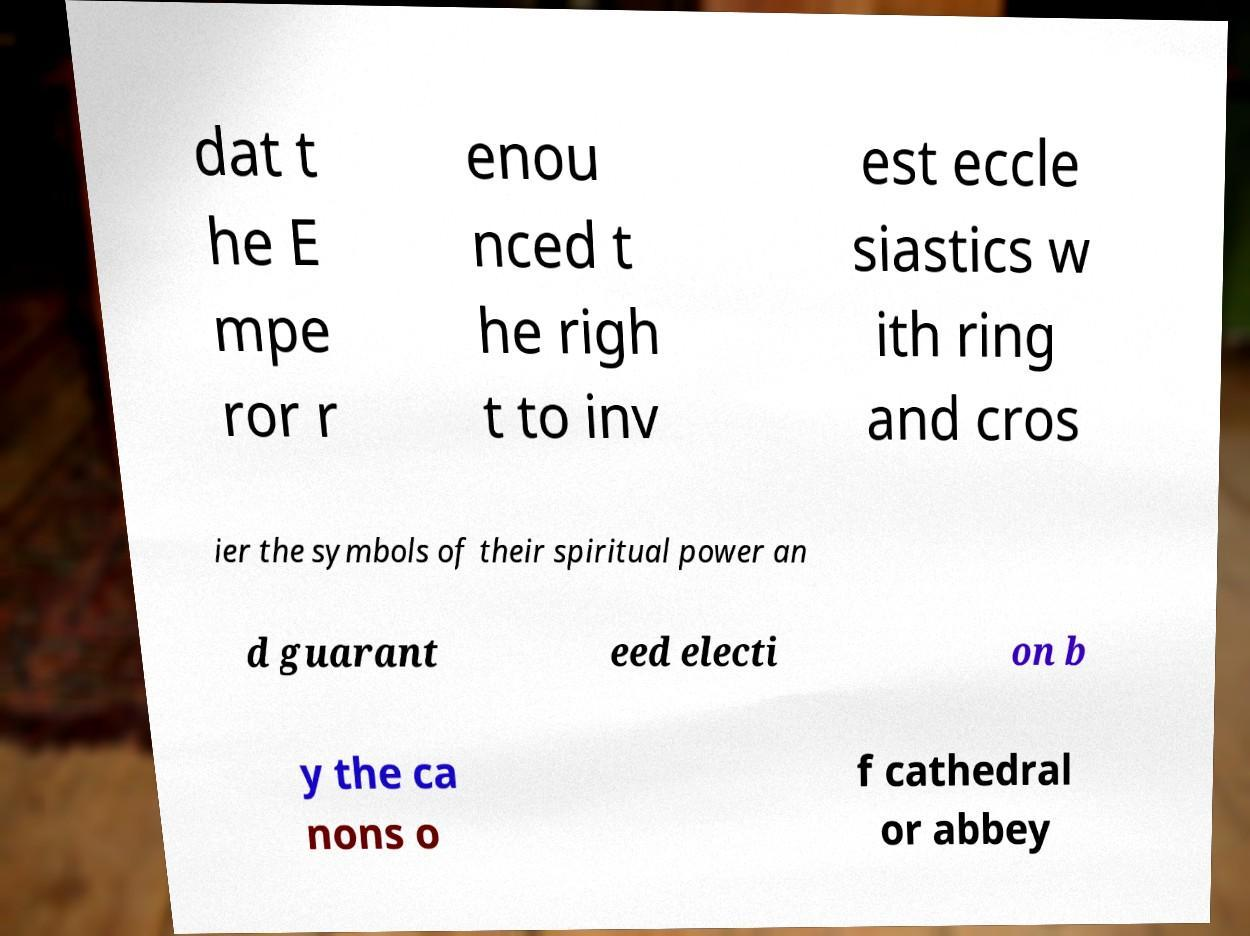Can you accurately transcribe the text from the provided image for me? dat t he E mpe ror r enou nced t he righ t to inv est eccle siastics w ith ring and cros ier the symbols of their spiritual power an d guarant eed electi on b y the ca nons o f cathedral or abbey 